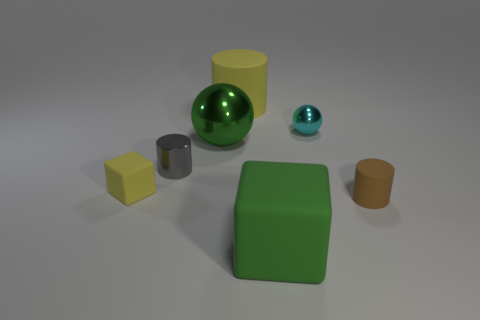There is a matte object that is the same color as the small cube; what size is it?
Your response must be concise. Large. What number of other things are the same size as the green sphere?
Your answer should be very brief. 2. The matte cylinder behind the large metallic object is what color?
Provide a succinct answer. Yellow. Is the material of the yellow object in front of the tiny shiny cylinder the same as the big green block?
Give a very brief answer. Yes. What number of matte objects are on the left side of the small brown cylinder and to the right of the green shiny thing?
Provide a short and direct response. 2. What is the color of the rubber cylinder in front of the tiny metallic cylinder behind the matte cube that is in front of the tiny yellow matte thing?
Ensure brevity in your answer.  Brown. What number of other things are the same shape as the cyan object?
Keep it short and to the point. 1. There is a green object behind the tiny gray object; is there a rubber object that is in front of it?
Your answer should be very brief. Yes. What number of shiny things are either small brown cylinders or large cubes?
Offer a terse response. 0. What is the small object that is to the right of the small yellow matte object and on the left side of the big yellow thing made of?
Offer a terse response. Metal. 